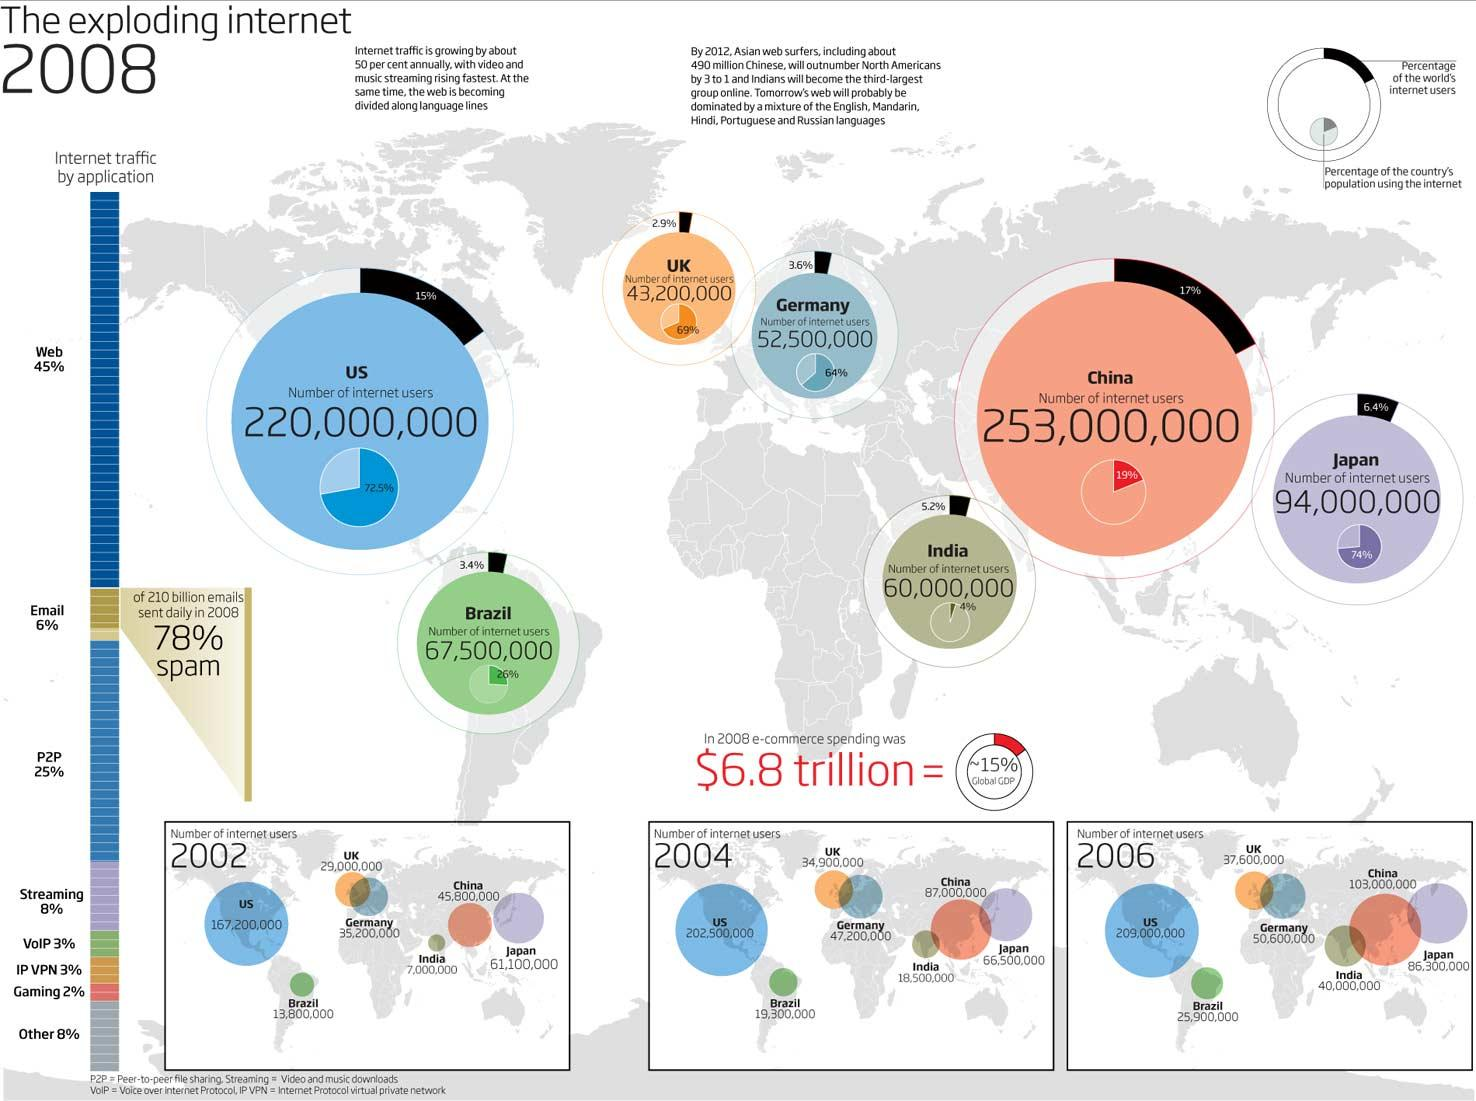List a handful of essential elements in this visual. Approximately 6.5% of the world's internet users are located in Germany and the United Kingdom. In Japan, 74% of the population uses the internet. According to recent statistics, emails and streaming cover approximately 14% of internet traffic. In 2002, the total number of internet users in the countries shown in Europe was approximately 64,200,000. During the period of 2004 to 2006, the number of internet users in Brazil increased by 66 million. 